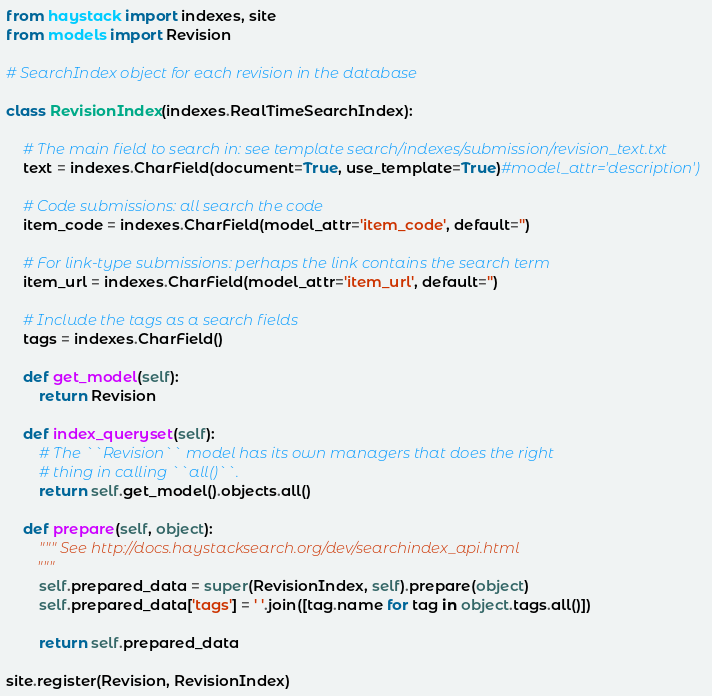<code> <loc_0><loc_0><loc_500><loc_500><_Python_>from haystack import indexes, site
from models import Revision

# SearchIndex object for each revision in the database

class RevisionIndex(indexes.RealTimeSearchIndex):

    # The main field to search in: see template search/indexes/submission/revision_text.txt
    text = indexes.CharField(document=True, use_template=True)#model_attr='description')

    # Code submissions: all search the code
    item_code = indexes.CharField(model_attr='item_code', default='')

    # For link-type submissions: perhaps the link contains the search term
    item_url = indexes.CharField(model_attr='item_url', default='')

    # Include the tags as a search fields
    tags = indexes.CharField()

    def get_model(self):
        return Revision

    def index_queryset(self):
        # The ``Revision`` model has its own managers that does the right
        # thing in calling ``all()``.
        return self.get_model().objects.all()

    def prepare(self, object):
        """ See http://docs.haystacksearch.org/dev/searchindex_api.html
        """
        self.prepared_data = super(RevisionIndex, self).prepare(object)
        self.prepared_data['tags'] = ' '.join([tag.name for tag in object.tags.all()])

        return self.prepared_data

site.register(Revision, RevisionIndex)
</code> 